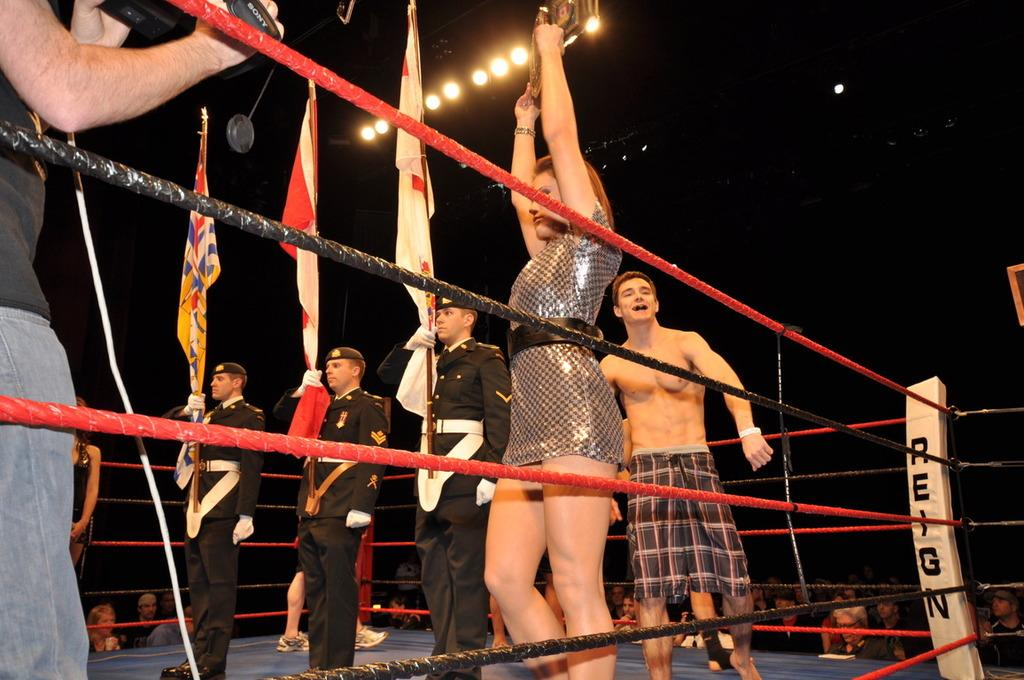<image>
Describe the image concisely. A boxer stands behind some men holding flags with the ring corner having the word reign on it. 